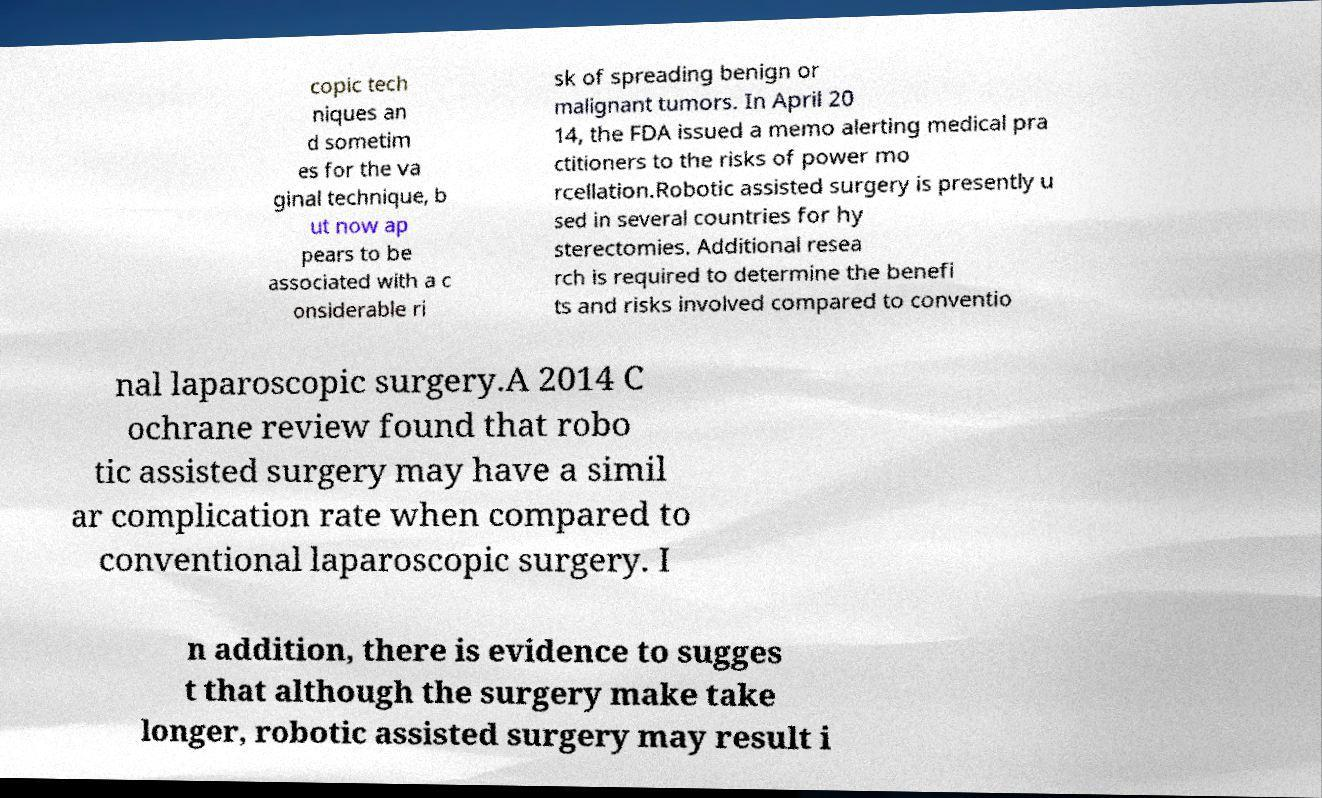There's text embedded in this image that I need extracted. Can you transcribe it verbatim? copic tech niques an d sometim es for the va ginal technique, b ut now ap pears to be associated with a c onsiderable ri sk of spreading benign or malignant tumors. In April 20 14, the FDA issued a memo alerting medical pra ctitioners to the risks of power mo rcellation.Robotic assisted surgery is presently u sed in several countries for hy sterectomies. Additional resea rch is required to determine the benefi ts and risks involved compared to conventio nal laparoscopic surgery.A 2014 C ochrane review found that robo tic assisted surgery may have a simil ar complication rate when compared to conventional laparoscopic surgery. I n addition, there is evidence to sugges t that although the surgery make take longer, robotic assisted surgery may result i 